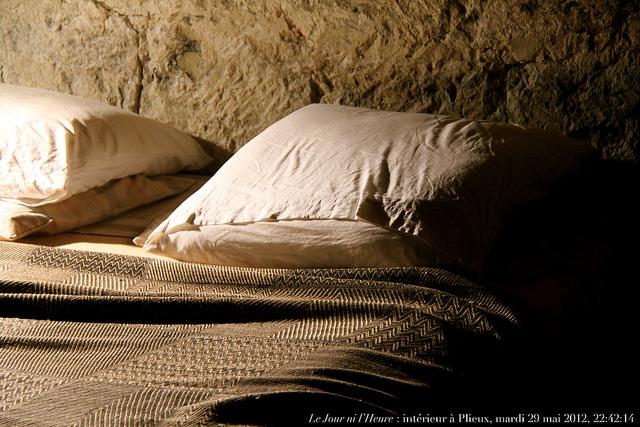How many pillows are there?
Give a very brief answer. 2. What color is the pillow case?
Answer briefly. Beige. What color is the sheet?
Short answer required. Brown. 